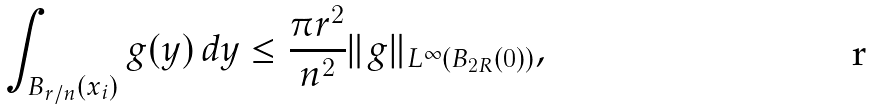<formula> <loc_0><loc_0><loc_500><loc_500>\int _ { B _ { r / n } ( x _ { i } ) } g { ( y ) \, d y } \leq { \frac { \pi r ^ { 2 } } { n ^ { 2 } } \| g \| _ { L ^ { \infty } ( B _ { 2 R } ( 0 ) ) } } ,</formula> 